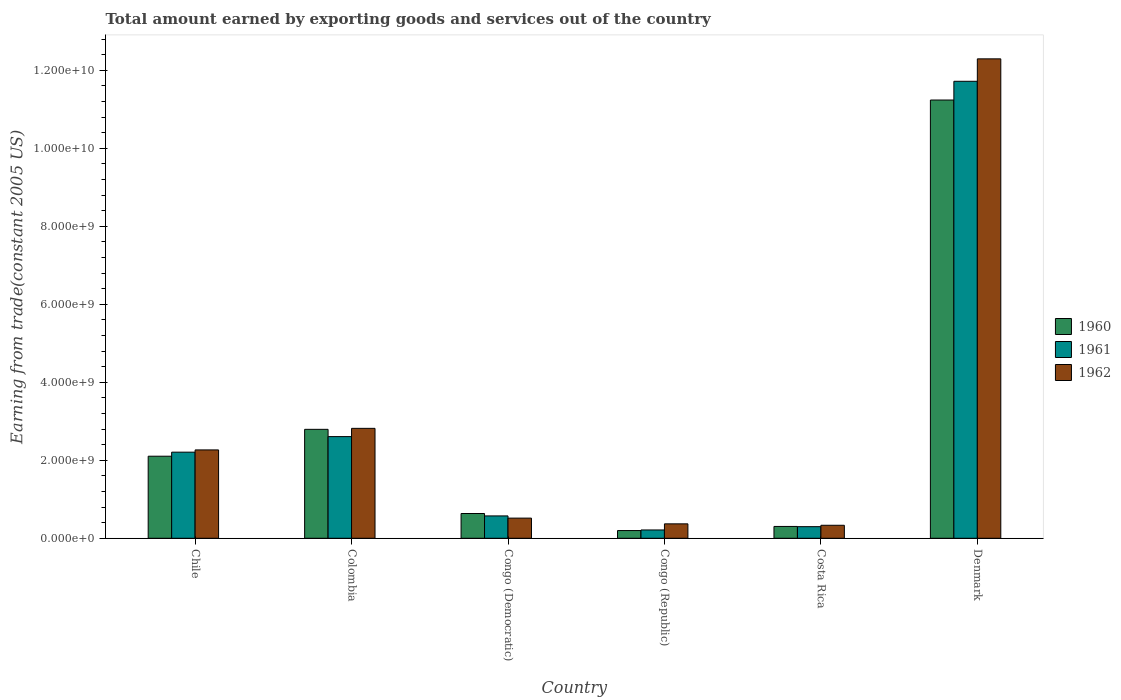Are the number of bars per tick equal to the number of legend labels?
Offer a very short reply. Yes. Are the number of bars on each tick of the X-axis equal?
Make the answer very short. Yes. How many bars are there on the 4th tick from the right?
Your response must be concise. 3. What is the label of the 4th group of bars from the left?
Your answer should be compact. Congo (Republic). In how many cases, is the number of bars for a given country not equal to the number of legend labels?
Your answer should be very brief. 0. What is the total amount earned by exporting goods and services in 1962 in Chile?
Offer a very short reply. 2.27e+09. Across all countries, what is the maximum total amount earned by exporting goods and services in 1961?
Provide a short and direct response. 1.17e+1. Across all countries, what is the minimum total amount earned by exporting goods and services in 1961?
Give a very brief answer. 2.13e+08. In which country was the total amount earned by exporting goods and services in 1960 minimum?
Keep it short and to the point. Congo (Republic). What is the total total amount earned by exporting goods and services in 1962 in the graph?
Keep it short and to the point. 1.86e+1. What is the difference between the total amount earned by exporting goods and services in 1960 in Congo (Democratic) and that in Costa Rica?
Your answer should be compact. 3.32e+08. What is the difference between the total amount earned by exporting goods and services in 1962 in Costa Rica and the total amount earned by exporting goods and services in 1961 in Colombia?
Provide a short and direct response. -2.27e+09. What is the average total amount earned by exporting goods and services in 1961 per country?
Your answer should be compact. 2.94e+09. What is the difference between the total amount earned by exporting goods and services of/in 1962 and total amount earned by exporting goods and services of/in 1961 in Denmark?
Offer a terse response. 5.76e+08. What is the ratio of the total amount earned by exporting goods and services in 1960 in Colombia to that in Congo (Republic)?
Your answer should be compact. 14.09. Is the difference between the total amount earned by exporting goods and services in 1962 in Colombia and Costa Rica greater than the difference between the total amount earned by exporting goods and services in 1961 in Colombia and Costa Rica?
Your response must be concise. Yes. What is the difference between the highest and the second highest total amount earned by exporting goods and services in 1961?
Your answer should be compact. -9.51e+09. What is the difference between the highest and the lowest total amount earned by exporting goods and services in 1961?
Ensure brevity in your answer.  1.15e+1. In how many countries, is the total amount earned by exporting goods and services in 1961 greater than the average total amount earned by exporting goods and services in 1961 taken over all countries?
Make the answer very short. 1. Is it the case that in every country, the sum of the total amount earned by exporting goods and services in 1961 and total amount earned by exporting goods and services in 1962 is greater than the total amount earned by exporting goods and services in 1960?
Provide a succinct answer. Yes. How many countries are there in the graph?
Give a very brief answer. 6. Are the values on the major ticks of Y-axis written in scientific E-notation?
Provide a succinct answer. Yes. Does the graph contain grids?
Your response must be concise. No. How many legend labels are there?
Your response must be concise. 3. What is the title of the graph?
Provide a succinct answer. Total amount earned by exporting goods and services out of the country. Does "1971" appear as one of the legend labels in the graph?
Keep it short and to the point. No. What is the label or title of the X-axis?
Your answer should be compact. Country. What is the label or title of the Y-axis?
Keep it short and to the point. Earning from trade(constant 2005 US). What is the Earning from trade(constant 2005 US) of 1960 in Chile?
Offer a terse response. 2.10e+09. What is the Earning from trade(constant 2005 US) of 1961 in Chile?
Keep it short and to the point. 2.21e+09. What is the Earning from trade(constant 2005 US) of 1962 in Chile?
Keep it short and to the point. 2.27e+09. What is the Earning from trade(constant 2005 US) of 1960 in Colombia?
Make the answer very short. 2.79e+09. What is the Earning from trade(constant 2005 US) in 1961 in Colombia?
Ensure brevity in your answer.  2.61e+09. What is the Earning from trade(constant 2005 US) of 1962 in Colombia?
Your answer should be very brief. 2.82e+09. What is the Earning from trade(constant 2005 US) of 1960 in Congo (Democratic)?
Provide a short and direct response. 6.35e+08. What is the Earning from trade(constant 2005 US) of 1961 in Congo (Democratic)?
Make the answer very short. 5.73e+08. What is the Earning from trade(constant 2005 US) in 1962 in Congo (Democratic)?
Keep it short and to the point. 5.17e+08. What is the Earning from trade(constant 2005 US) of 1960 in Congo (Republic)?
Your answer should be very brief. 1.98e+08. What is the Earning from trade(constant 2005 US) of 1961 in Congo (Republic)?
Offer a terse response. 2.13e+08. What is the Earning from trade(constant 2005 US) in 1962 in Congo (Republic)?
Your answer should be compact. 3.70e+08. What is the Earning from trade(constant 2005 US) of 1960 in Costa Rica?
Your answer should be compact. 3.03e+08. What is the Earning from trade(constant 2005 US) in 1961 in Costa Rica?
Your response must be concise. 2.98e+08. What is the Earning from trade(constant 2005 US) of 1962 in Costa Rica?
Give a very brief answer. 3.33e+08. What is the Earning from trade(constant 2005 US) of 1960 in Denmark?
Provide a short and direct response. 1.12e+1. What is the Earning from trade(constant 2005 US) of 1961 in Denmark?
Provide a succinct answer. 1.17e+1. What is the Earning from trade(constant 2005 US) of 1962 in Denmark?
Ensure brevity in your answer.  1.23e+1. Across all countries, what is the maximum Earning from trade(constant 2005 US) of 1960?
Offer a terse response. 1.12e+1. Across all countries, what is the maximum Earning from trade(constant 2005 US) in 1961?
Make the answer very short. 1.17e+1. Across all countries, what is the maximum Earning from trade(constant 2005 US) of 1962?
Offer a very short reply. 1.23e+1. Across all countries, what is the minimum Earning from trade(constant 2005 US) of 1960?
Offer a very short reply. 1.98e+08. Across all countries, what is the minimum Earning from trade(constant 2005 US) in 1961?
Provide a short and direct response. 2.13e+08. Across all countries, what is the minimum Earning from trade(constant 2005 US) of 1962?
Provide a succinct answer. 3.33e+08. What is the total Earning from trade(constant 2005 US) of 1960 in the graph?
Ensure brevity in your answer.  1.73e+1. What is the total Earning from trade(constant 2005 US) in 1961 in the graph?
Offer a very short reply. 1.76e+1. What is the total Earning from trade(constant 2005 US) of 1962 in the graph?
Give a very brief answer. 1.86e+1. What is the difference between the Earning from trade(constant 2005 US) in 1960 in Chile and that in Colombia?
Your answer should be compact. -6.89e+08. What is the difference between the Earning from trade(constant 2005 US) in 1961 in Chile and that in Colombia?
Provide a succinct answer. -3.99e+08. What is the difference between the Earning from trade(constant 2005 US) of 1962 in Chile and that in Colombia?
Offer a terse response. -5.53e+08. What is the difference between the Earning from trade(constant 2005 US) of 1960 in Chile and that in Congo (Democratic)?
Keep it short and to the point. 1.47e+09. What is the difference between the Earning from trade(constant 2005 US) in 1961 in Chile and that in Congo (Democratic)?
Provide a succinct answer. 1.64e+09. What is the difference between the Earning from trade(constant 2005 US) of 1962 in Chile and that in Congo (Democratic)?
Provide a short and direct response. 1.75e+09. What is the difference between the Earning from trade(constant 2005 US) in 1960 in Chile and that in Congo (Republic)?
Your answer should be compact. 1.91e+09. What is the difference between the Earning from trade(constant 2005 US) of 1961 in Chile and that in Congo (Republic)?
Your answer should be compact. 2.00e+09. What is the difference between the Earning from trade(constant 2005 US) in 1962 in Chile and that in Congo (Republic)?
Offer a terse response. 1.90e+09. What is the difference between the Earning from trade(constant 2005 US) of 1960 in Chile and that in Costa Rica?
Ensure brevity in your answer.  1.80e+09. What is the difference between the Earning from trade(constant 2005 US) of 1961 in Chile and that in Costa Rica?
Make the answer very short. 1.91e+09. What is the difference between the Earning from trade(constant 2005 US) of 1962 in Chile and that in Costa Rica?
Keep it short and to the point. 1.93e+09. What is the difference between the Earning from trade(constant 2005 US) in 1960 in Chile and that in Denmark?
Offer a terse response. -9.13e+09. What is the difference between the Earning from trade(constant 2005 US) of 1961 in Chile and that in Denmark?
Your response must be concise. -9.51e+09. What is the difference between the Earning from trade(constant 2005 US) of 1962 in Chile and that in Denmark?
Your response must be concise. -1.00e+1. What is the difference between the Earning from trade(constant 2005 US) in 1960 in Colombia and that in Congo (Democratic)?
Offer a terse response. 2.16e+09. What is the difference between the Earning from trade(constant 2005 US) of 1961 in Colombia and that in Congo (Democratic)?
Keep it short and to the point. 2.03e+09. What is the difference between the Earning from trade(constant 2005 US) in 1962 in Colombia and that in Congo (Democratic)?
Make the answer very short. 2.30e+09. What is the difference between the Earning from trade(constant 2005 US) of 1960 in Colombia and that in Congo (Republic)?
Offer a very short reply. 2.60e+09. What is the difference between the Earning from trade(constant 2005 US) of 1961 in Colombia and that in Congo (Republic)?
Your response must be concise. 2.39e+09. What is the difference between the Earning from trade(constant 2005 US) of 1962 in Colombia and that in Congo (Republic)?
Ensure brevity in your answer.  2.45e+09. What is the difference between the Earning from trade(constant 2005 US) in 1960 in Colombia and that in Costa Rica?
Give a very brief answer. 2.49e+09. What is the difference between the Earning from trade(constant 2005 US) in 1961 in Colombia and that in Costa Rica?
Your response must be concise. 2.31e+09. What is the difference between the Earning from trade(constant 2005 US) of 1962 in Colombia and that in Costa Rica?
Make the answer very short. 2.49e+09. What is the difference between the Earning from trade(constant 2005 US) of 1960 in Colombia and that in Denmark?
Make the answer very short. -8.44e+09. What is the difference between the Earning from trade(constant 2005 US) of 1961 in Colombia and that in Denmark?
Offer a terse response. -9.11e+09. What is the difference between the Earning from trade(constant 2005 US) of 1962 in Colombia and that in Denmark?
Ensure brevity in your answer.  -9.48e+09. What is the difference between the Earning from trade(constant 2005 US) of 1960 in Congo (Democratic) and that in Congo (Republic)?
Ensure brevity in your answer.  4.37e+08. What is the difference between the Earning from trade(constant 2005 US) in 1961 in Congo (Democratic) and that in Congo (Republic)?
Your answer should be compact. 3.60e+08. What is the difference between the Earning from trade(constant 2005 US) of 1962 in Congo (Democratic) and that in Congo (Republic)?
Provide a short and direct response. 1.47e+08. What is the difference between the Earning from trade(constant 2005 US) in 1960 in Congo (Democratic) and that in Costa Rica?
Make the answer very short. 3.32e+08. What is the difference between the Earning from trade(constant 2005 US) of 1961 in Congo (Democratic) and that in Costa Rica?
Provide a short and direct response. 2.76e+08. What is the difference between the Earning from trade(constant 2005 US) of 1962 in Congo (Democratic) and that in Costa Rica?
Offer a very short reply. 1.84e+08. What is the difference between the Earning from trade(constant 2005 US) in 1960 in Congo (Democratic) and that in Denmark?
Give a very brief answer. -1.06e+1. What is the difference between the Earning from trade(constant 2005 US) of 1961 in Congo (Democratic) and that in Denmark?
Give a very brief answer. -1.11e+1. What is the difference between the Earning from trade(constant 2005 US) in 1962 in Congo (Democratic) and that in Denmark?
Make the answer very short. -1.18e+1. What is the difference between the Earning from trade(constant 2005 US) in 1960 in Congo (Republic) and that in Costa Rica?
Provide a succinct answer. -1.05e+08. What is the difference between the Earning from trade(constant 2005 US) in 1961 in Congo (Republic) and that in Costa Rica?
Your answer should be compact. -8.47e+07. What is the difference between the Earning from trade(constant 2005 US) in 1962 in Congo (Republic) and that in Costa Rica?
Offer a very short reply. 3.67e+07. What is the difference between the Earning from trade(constant 2005 US) of 1960 in Congo (Republic) and that in Denmark?
Make the answer very short. -1.10e+1. What is the difference between the Earning from trade(constant 2005 US) in 1961 in Congo (Republic) and that in Denmark?
Your answer should be very brief. -1.15e+1. What is the difference between the Earning from trade(constant 2005 US) in 1962 in Congo (Republic) and that in Denmark?
Make the answer very short. -1.19e+1. What is the difference between the Earning from trade(constant 2005 US) of 1960 in Costa Rica and that in Denmark?
Your answer should be very brief. -1.09e+1. What is the difference between the Earning from trade(constant 2005 US) of 1961 in Costa Rica and that in Denmark?
Your answer should be compact. -1.14e+1. What is the difference between the Earning from trade(constant 2005 US) in 1962 in Costa Rica and that in Denmark?
Your answer should be compact. -1.20e+1. What is the difference between the Earning from trade(constant 2005 US) in 1960 in Chile and the Earning from trade(constant 2005 US) in 1961 in Colombia?
Keep it short and to the point. -5.03e+08. What is the difference between the Earning from trade(constant 2005 US) in 1960 in Chile and the Earning from trade(constant 2005 US) in 1962 in Colombia?
Offer a very short reply. -7.14e+08. What is the difference between the Earning from trade(constant 2005 US) in 1961 in Chile and the Earning from trade(constant 2005 US) in 1962 in Colombia?
Offer a terse response. -6.10e+08. What is the difference between the Earning from trade(constant 2005 US) in 1960 in Chile and the Earning from trade(constant 2005 US) in 1961 in Congo (Democratic)?
Make the answer very short. 1.53e+09. What is the difference between the Earning from trade(constant 2005 US) of 1960 in Chile and the Earning from trade(constant 2005 US) of 1962 in Congo (Democratic)?
Provide a short and direct response. 1.59e+09. What is the difference between the Earning from trade(constant 2005 US) of 1961 in Chile and the Earning from trade(constant 2005 US) of 1962 in Congo (Democratic)?
Ensure brevity in your answer.  1.69e+09. What is the difference between the Earning from trade(constant 2005 US) of 1960 in Chile and the Earning from trade(constant 2005 US) of 1961 in Congo (Republic)?
Offer a terse response. 1.89e+09. What is the difference between the Earning from trade(constant 2005 US) in 1960 in Chile and the Earning from trade(constant 2005 US) in 1962 in Congo (Republic)?
Provide a succinct answer. 1.73e+09. What is the difference between the Earning from trade(constant 2005 US) in 1961 in Chile and the Earning from trade(constant 2005 US) in 1962 in Congo (Republic)?
Provide a short and direct response. 1.84e+09. What is the difference between the Earning from trade(constant 2005 US) of 1960 in Chile and the Earning from trade(constant 2005 US) of 1961 in Costa Rica?
Make the answer very short. 1.81e+09. What is the difference between the Earning from trade(constant 2005 US) in 1960 in Chile and the Earning from trade(constant 2005 US) in 1962 in Costa Rica?
Offer a terse response. 1.77e+09. What is the difference between the Earning from trade(constant 2005 US) of 1961 in Chile and the Earning from trade(constant 2005 US) of 1962 in Costa Rica?
Your answer should be compact. 1.87e+09. What is the difference between the Earning from trade(constant 2005 US) of 1960 in Chile and the Earning from trade(constant 2005 US) of 1961 in Denmark?
Your answer should be compact. -9.61e+09. What is the difference between the Earning from trade(constant 2005 US) of 1960 in Chile and the Earning from trade(constant 2005 US) of 1962 in Denmark?
Provide a short and direct response. -1.02e+1. What is the difference between the Earning from trade(constant 2005 US) in 1961 in Chile and the Earning from trade(constant 2005 US) in 1962 in Denmark?
Give a very brief answer. -1.01e+1. What is the difference between the Earning from trade(constant 2005 US) of 1960 in Colombia and the Earning from trade(constant 2005 US) of 1961 in Congo (Democratic)?
Provide a short and direct response. 2.22e+09. What is the difference between the Earning from trade(constant 2005 US) in 1960 in Colombia and the Earning from trade(constant 2005 US) in 1962 in Congo (Democratic)?
Your answer should be compact. 2.28e+09. What is the difference between the Earning from trade(constant 2005 US) of 1961 in Colombia and the Earning from trade(constant 2005 US) of 1962 in Congo (Democratic)?
Offer a terse response. 2.09e+09. What is the difference between the Earning from trade(constant 2005 US) of 1960 in Colombia and the Earning from trade(constant 2005 US) of 1961 in Congo (Republic)?
Offer a very short reply. 2.58e+09. What is the difference between the Earning from trade(constant 2005 US) in 1960 in Colombia and the Earning from trade(constant 2005 US) in 1962 in Congo (Republic)?
Provide a succinct answer. 2.42e+09. What is the difference between the Earning from trade(constant 2005 US) in 1961 in Colombia and the Earning from trade(constant 2005 US) in 1962 in Congo (Republic)?
Ensure brevity in your answer.  2.24e+09. What is the difference between the Earning from trade(constant 2005 US) in 1960 in Colombia and the Earning from trade(constant 2005 US) in 1961 in Costa Rica?
Offer a very short reply. 2.50e+09. What is the difference between the Earning from trade(constant 2005 US) in 1960 in Colombia and the Earning from trade(constant 2005 US) in 1962 in Costa Rica?
Ensure brevity in your answer.  2.46e+09. What is the difference between the Earning from trade(constant 2005 US) in 1961 in Colombia and the Earning from trade(constant 2005 US) in 1962 in Costa Rica?
Keep it short and to the point. 2.27e+09. What is the difference between the Earning from trade(constant 2005 US) in 1960 in Colombia and the Earning from trade(constant 2005 US) in 1961 in Denmark?
Your answer should be compact. -8.93e+09. What is the difference between the Earning from trade(constant 2005 US) in 1960 in Colombia and the Earning from trade(constant 2005 US) in 1962 in Denmark?
Give a very brief answer. -9.50e+09. What is the difference between the Earning from trade(constant 2005 US) in 1961 in Colombia and the Earning from trade(constant 2005 US) in 1962 in Denmark?
Keep it short and to the point. -9.69e+09. What is the difference between the Earning from trade(constant 2005 US) in 1960 in Congo (Democratic) and the Earning from trade(constant 2005 US) in 1961 in Congo (Republic)?
Offer a very short reply. 4.22e+08. What is the difference between the Earning from trade(constant 2005 US) of 1960 in Congo (Democratic) and the Earning from trade(constant 2005 US) of 1962 in Congo (Republic)?
Keep it short and to the point. 2.65e+08. What is the difference between the Earning from trade(constant 2005 US) in 1961 in Congo (Democratic) and the Earning from trade(constant 2005 US) in 1962 in Congo (Republic)?
Keep it short and to the point. 2.03e+08. What is the difference between the Earning from trade(constant 2005 US) of 1960 in Congo (Democratic) and the Earning from trade(constant 2005 US) of 1961 in Costa Rica?
Your answer should be very brief. 3.38e+08. What is the difference between the Earning from trade(constant 2005 US) of 1960 in Congo (Democratic) and the Earning from trade(constant 2005 US) of 1962 in Costa Rica?
Your answer should be compact. 3.02e+08. What is the difference between the Earning from trade(constant 2005 US) in 1961 in Congo (Democratic) and the Earning from trade(constant 2005 US) in 1962 in Costa Rica?
Provide a succinct answer. 2.40e+08. What is the difference between the Earning from trade(constant 2005 US) in 1960 in Congo (Democratic) and the Earning from trade(constant 2005 US) in 1961 in Denmark?
Provide a succinct answer. -1.11e+1. What is the difference between the Earning from trade(constant 2005 US) of 1960 in Congo (Democratic) and the Earning from trade(constant 2005 US) of 1962 in Denmark?
Keep it short and to the point. -1.17e+1. What is the difference between the Earning from trade(constant 2005 US) of 1961 in Congo (Democratic) and the Earning from trade(constant 2005 US) of 1962 in Denmark?
Your answer should be compact. -1.17e+1. What is the difference between the Earning from trade(constant 2005 US) of 1960 in Congo (Republic) and the Earning from trade(constant 2005 US) of 1961 in Costa Rica?
Keep it short and to the point. -9.96e+07. What is the difference between the Earning from trade(constant 2005 US) in 1960 in Congo (Republic) and the Earning from trade(constant 2005 US) in 1962 in Costa Rica?
Offer a terse response. -1.35e+08. What is the difference between the Earning from trade(constant 2005 US) in 1961 in Congo (Republic) and the Earning from trade(constant 2005 US) in 1962 in Costa Rica?
Keep it short and to the point. -1.20e+08. What is the difference between the Earning from trade(constant 2005 US) of 1960 in Congo (Republic) and the Earning from trade(constant 2005 US) of 1961 in Denmark?
Ensure brevity in your answer.  -1.15e+1. What is the difference between the Earning from trade(constant 2005 US) of 1960 in Congo (Republic) and the Earning from trade(constant 2005 US) of 1962 in Denmark?
Your answer should be compact. -1.21e+1. What is the difference between the Earning from trade(constant 2005 US) of 1961 in Congo (Republic) and the Earning from trade(constant 2005 US) of 1962 in Denmark?
Make the answer very short. -1.21e+1. What is the difference between the Earning from trade(constant 2005 US) of 1960 in Costa Rica and the Earning from trade(constant 2005 US) of 1961 in Denmark?
Offer a terse response. -1.14e+1. What is the difference between the Earning from trade(constant 2005 US) in 1960 in Costa Rica and the Earning from trade(constant 2005 US) in 1962 in Denmark?
Make the answer very short. -1.20e+1. What is the difference between the Earning from trade(constant 2005 US) in 1961 in Costa Rica and the Earning from trade(constant 2005 US) in 1962 in Denmark?
Give a very brief answer. -1.20e+1. What is the average Earning from trade(constant 2005 US) of 1960 per country?
Provide a succinct answer. 2.88e+09. What is the average Earning from trade(constant 2005 US) of 1961 per country?
Your response must be concise. 2.94e+09. What is the average Earning from trade(constant 2005 US) in 1962 per country?
Your answer should be very brief. 3.10e+09. What is the difference between the Earning from trade(constant 2005 US) of 1960 and Earning from trade(constant 2005 US) of 1961 in Chile?
Your answer should be compact. -1.04e+08. What is the difference between the Earning from trade(constant 2005 US) of 1960 and Earning from trade(constant 2005 US) of 1962 in Chile?
Offer a very short reply. -1.62e+08. What is the difference between the Earning from trade(constant 2005 US) of 1961 and Earning from trade(constant 2005 US) of 1962 in Chile?
Offer a terse response. -5.76e+07. What is the difference between the Earning from trade(constant 2005 US) in 1960 and Earning from trade(constant 2005 US) in 1961 in Colombia?
Your answer should be compact. 1.86e+08. What is the difference between the Earning from trade(constant 2005 US) of 1960 and Earning from trade(constant 2005 US) of 1962 in Colombia?
Give a very brief answer. -2.49e+07. What is the difference between the Earning from trade(constant 2005 US) of 1961 and Earning from trade(constant 2005 US) of 1962 in Colombia?
Keep it short and to the point. -2.11e+08. What is the difference between the Earning from trade(constant 2005 US) in 1960 and Earning from trade(constant 2005 US) in 1961 in Congo (Democratic)?
Make the answer very short. 6.20e+07. What is the difference between the Earning from trade(constant 2005 US) in 1960 and Earning from trade(constant 2005 US) in 1962 in Congo (Democratic)?
Keep it short and to the point. 1.18e+08. What is the difference between the Earning from trade(constant 2005 US) in 1961 and Earning from trade(constant 2005 US) in 1962 in Congo (Democratic)?
Your response must be concise. 5.64e+07. What is the difference between the Earning from trade(constant 2005 US) of 1960 and Earning from trade(constant 2005 US) of 1961 in Congo (Republic)?
Offer a very short reply. -1.49e+07. What is the difference between the Earning from trade(constant 2005 US) of 1960 and Earning from trade(constant 2005 US) of 1962 in Congo (Republic)?
Provide a short and direct response. -1.72e+08. What is the difference between the Earning from trade(constant 2005 US) of 1961 and Earning from trade(constant 2005 US) of 1962 in Congo (Republic)?
Your answer should be compact. -1.57e+08. What is the difference between the Earning from trade(constant 2005 US) of 1960 and Earning from trade(constant 2005 US) of 1961 in Costa Rica?
Provide a succinct answer. 5.57e+06. What is the difference between the Earning from trade(constant 2005 US) of 1960 and Earning from trade(constant 2005 US) of 1962 in Costa Rica?
Keep it short and to the point. -3.00e+07. What is the difference between the Earning from trade(constant 2005 US) in 1961 and Earning from trade(constant 2005 US) in 1962 in Costa Rica?
Keep it short and to the point. -3.56e+07. What is the difference between the Earning from trade(constant 2005 US) of 1960 and Earning from trade(constant 2005 US) of 1961 in Denmark?
Provide a short and direct response. -4.81e+08. What is the difference between the Earning from trade(constant 2005 US) of 1960 and Earning from trade(constant 2005 US) of 1962 in Denmark?
Provide a short and direct response. -1.06e+09. What is the difference between the Earning from trade(constant 2005 US) in 1961 and Earning from trade(constant 2005 US) in 1962 in Denmark?
Give a very brief answer. -5.76e+08. What is the ratio of the Earning from trade(constant 2005 US) in 1960 in Chile to that in Colombia?
Make the answer very short. 0.75. What is the ratio of the Earning from trade(constant 2005 US) of 1961 in Chile to that in Colombia?
Give a very brief answer. 0.85. What is the ratio of the Earning from trade(constant 2005 US) in 1962 in Chile to that in Colombia?
Provide a short and direct response. 0.8. What is the ratio of the Earning from trade(constant 2005 US) in 1960 in Chile to that in Congo (Democratic)?
Your answer should be compact. 3.31. What is the ratio of the Earning from trade(constant 2005 US) of 1961 in Chile to that in Congo (Democratic)?
Provide a succinct answer. 3.85. What is the ratio of the Earning from trade(constant 2005 US) of 1962 in Chile to that in Congo (Democratic)?
Your answer should be compact. 4.38. What is the ratio of the Earning from trade(constant 2005 US) in 1960 in Chile to that in Congo (Republic)?
Your answer should be very brief. 10.61. What is the ratio of the Earning from trade(constant 2005 US) of 1961 in Chile to that in Congo (Republic)?
Give a very brief answer. 10.36. What is the ratio of the Earning from trade(constant 2005 US) of 1962 in Chile to that in Congo (Republic)?
Offer a very short reply. 6.12. What is the ratio of the Earning from trade(constant 2005 US) in 1960 in Chile to that in Costa Rica?
Make the answer very short. 6.93. What is the ratio of the Earning from trade(constant 2005 US) of 1961 in Chile to that in Costa Rica?
Offer a very short reply. 7.41. What is the ratio of the Earning from trade(constant 2005 US) in 1962 in Chile to that in Costa Rica?
Your response must be concise. 6.8. What is the ratio of the Earning from trade(constant 2005 US) of 1960 in Chile to that in Denmark?
Provide a succinct answer. 0.19. What is the ratio of the Earning from trade(constant 2005 US) of 1961 in Chile to that in Denmark?
Your response must be concise. 0.19. What is the ratio of the Earning from trade(constant 2005 US) in 1962 in Chile to that in Denmark?
Give a very brief answer. 0.18. What is the ratio of the Earning from trade(constant 2005 US) in 1960 in Colombia to that in Congo (Democratic)?
Keep it short and to the point. 4.4. What is the ratio of the Earning from trade(constant 2005 US) of 1961 in Colombia to that in Congo (Democratic)?
Your answer should be very brief. 4.55. What is the ratio of the Earning from trade(constant 2005 US) in 1962 in Colombia to that in Congo (Democratic)?
Ensure brevity in your answer.  5.45. What is the ratio of the Earning from trade(constant 2005 US) in 1960 in Colombia to that in Congo (Republic)?
Offer a very short reply. 14.09. What is the ratio of the Earning from trade(constant 2005 US) of 1961 in Colombia to that in Congo (Republic)?
Give a very brief answer. 12.23. What is the ratio of the Earning from trade(constant 2005 US) in 1962 in Colombia to that in Congo (Republic)?
Provide a succinct answer. 7.62. What is the ratio of the Earning from trade(constant 2005 US) of 1960 in Colombia to that in Costa Rica?
Your answer should be compact. 9.21. What is the ratio of the Earning from trade(constant 2005 US) of 1961 in Colombia to that in Costa Rica?
Give a very brief answer. 8.75. What is the ratio of the Earning from trade(constant 2005 US) of 1962 in Colombia to that in Costa Rica?
Ensure brevity in your answer.  8.45. What is the ratio of the Earning from trade(constant 2005 US) of 1960 in Colombia to that in Denmark?
Make the answer very short. 0.25. What is the ratio of the Earning from trade(constant 2005 US) of 1961 in Colombia to that in Denmark?
Make the answer very short. 0.22. What is the ratio of the Earning from trade(constant 2005 US) in 1962 in Colombia to that in Denmark?
Make the answer very short. 0.23. What is the ratio of the Earning from trade(constant 2005 US) in 1960 in Congo (Democratic) to that in Congo (Republic)?
Make the answer very short. 3.2. What is the ratio of the Earning from trade(constant 2005 US) of 1961 in Congo (Democratic) to that in Congo (Republic)?
Offer a terse response. 2.69. What is the ratio of the Earning from trade(constant 2005 US) of 1962 in Congo (Democratic) to that in Congo (Republic)?
Your answer should be compact. 1.4. What is the ratio of the Earning from trade(constant 2005 US) of 1960 in Congo (Democratic) to that in Costa Rica?
Your response must be concise. 2.09. What is the ratio of the Earning from trade(constant 2005 US) in 1961 in Congo (Democratic) to that in Costa Rica?
Make the answer very short. 1.92. What is the ratio of the Earning from trade(constant 2005 US) in 1962 in Congo (Democratic) to that in Costa Rica?
Provide a short and direct response. 1.55. What is the ratio of the Earning from trade(constant 2005 US) of 1960 in Congo (Democratic) to that in Denmark?
Your response must be concise. 0.06. What is the ratio of the Earning from trade(constant 2005 US) of 1961 in Congo (Democratic) to that in Denmark?
Your response must be concise. 0.05. What is the ratio of the Earning from trade(constant 2005 US) in 1962 in Congo (Democratic) to that in Denmark?
Make the answer very short. 0.04. What is the ratio of the Earning from trade(constant 2005 US) of 1960 in Congo (Republic) to that in Costa Rica?
Give a very brief answer. 0.65. What is the ratio of the Earning from trade(constant 2005 US) in 1961 in Congo (Republic) to that in Costa Rica?
Ensure brevity in your answer.  0.72. What is the ratio of the Earning from trade(constant 2005 US) in 1962 in Congo (Republic) to that in Costa Rica?
Provide a short and direct response. 1.11. What is the ratio of the Earning from trade(constant 2005 US) in 1960 in Congo (Republic) to that in Denmark?
Make the answer very short. 0.02. What is the ratio of the Earning from trade(constant 2005 US) in 1961 in Congo (Republic) to that in Denmark?
Your response must be concise. 0.02. What is the ratio of the Earning from trade(constant 2005 US) in 1962 in Congo (Republic) to that in Denmark?
Your response must be concise. 0.03. What is the ratio of the Earning from trade(constant 2005 US) of 1960 in Costa Rica to that in Denmark?
Ensure brevity in your answer.  0.03. What is the ratio of the Earning from trade(constant 2005 US) in 1961 in Costa Rica to that in Denmark?
Your response must be concise. 0.03. What is the ratio of the Earning from trade(constant 2005 US) of 1962 in Costa Rica to that in Denmark?
Make the answer very short. 0.03. What is the difference between the highest and the second highest Earning from trade(constant 2005 US) in 1960?
Your answer should be compact. 8.44e+09. What is the difference between the highest and the second highest Earning from trade(constant 2005 US) in 1961?
Your answer should be compact. 9.11e+09. What is the difference between the highest and the second highest Earning from trade(constant 2005 US) in 1962?
Your answer should be very brief. 9.48e+09. What is the difference between the highest and the lowest Earning from trade(constant 2005 US) of 1960?
Ensure brevity in your answer.  1.10e+1. What is the difference between the highest and the lowest Earning from trade(constant 2005 US) of 1961?
Your response must be concise. 1.15e+1. What is the difference between the highest and the lowest Earning from trade(constant 2005 US) of 1962?
Provide a short and direct response. 1.20e+1. 